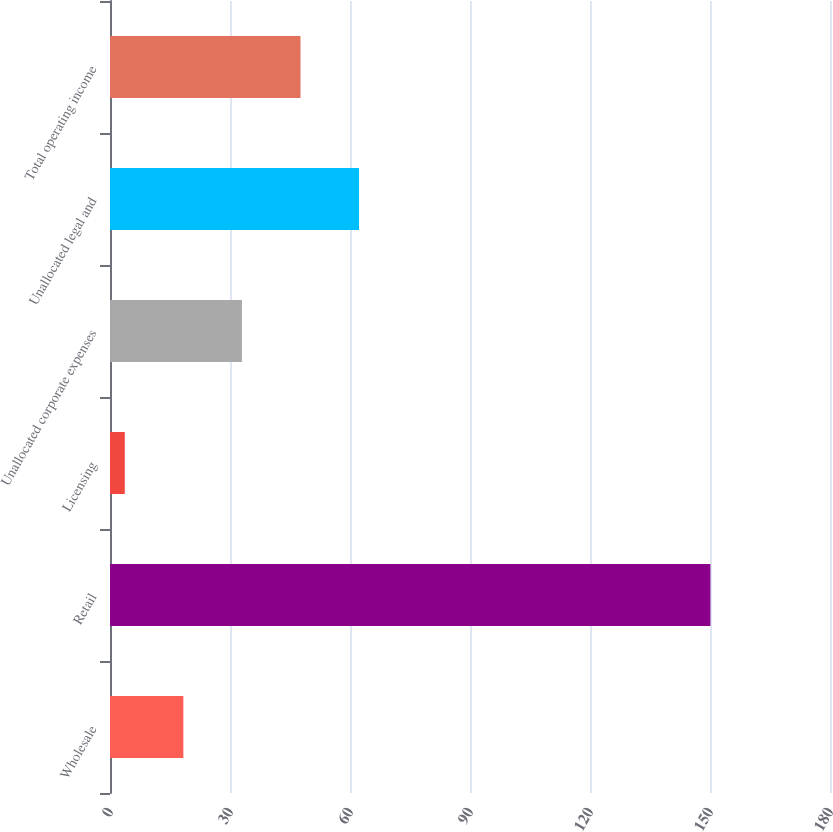Convert chart to OTSL. <chart><loc_0><loc_0><loc_500><loc_500><bar_chart><fcel>Wholesale<fcel>Retail<fcel>Licensing<fcel>Unallocated corporate expenses<fcel>Unallocated legal and<fcel>Total operating income<nl><fcel>18.34<fcel>150.1<fcel>3.7<fcel>32.98<fcel>62.26<fcel>47.62<nl></chart> 